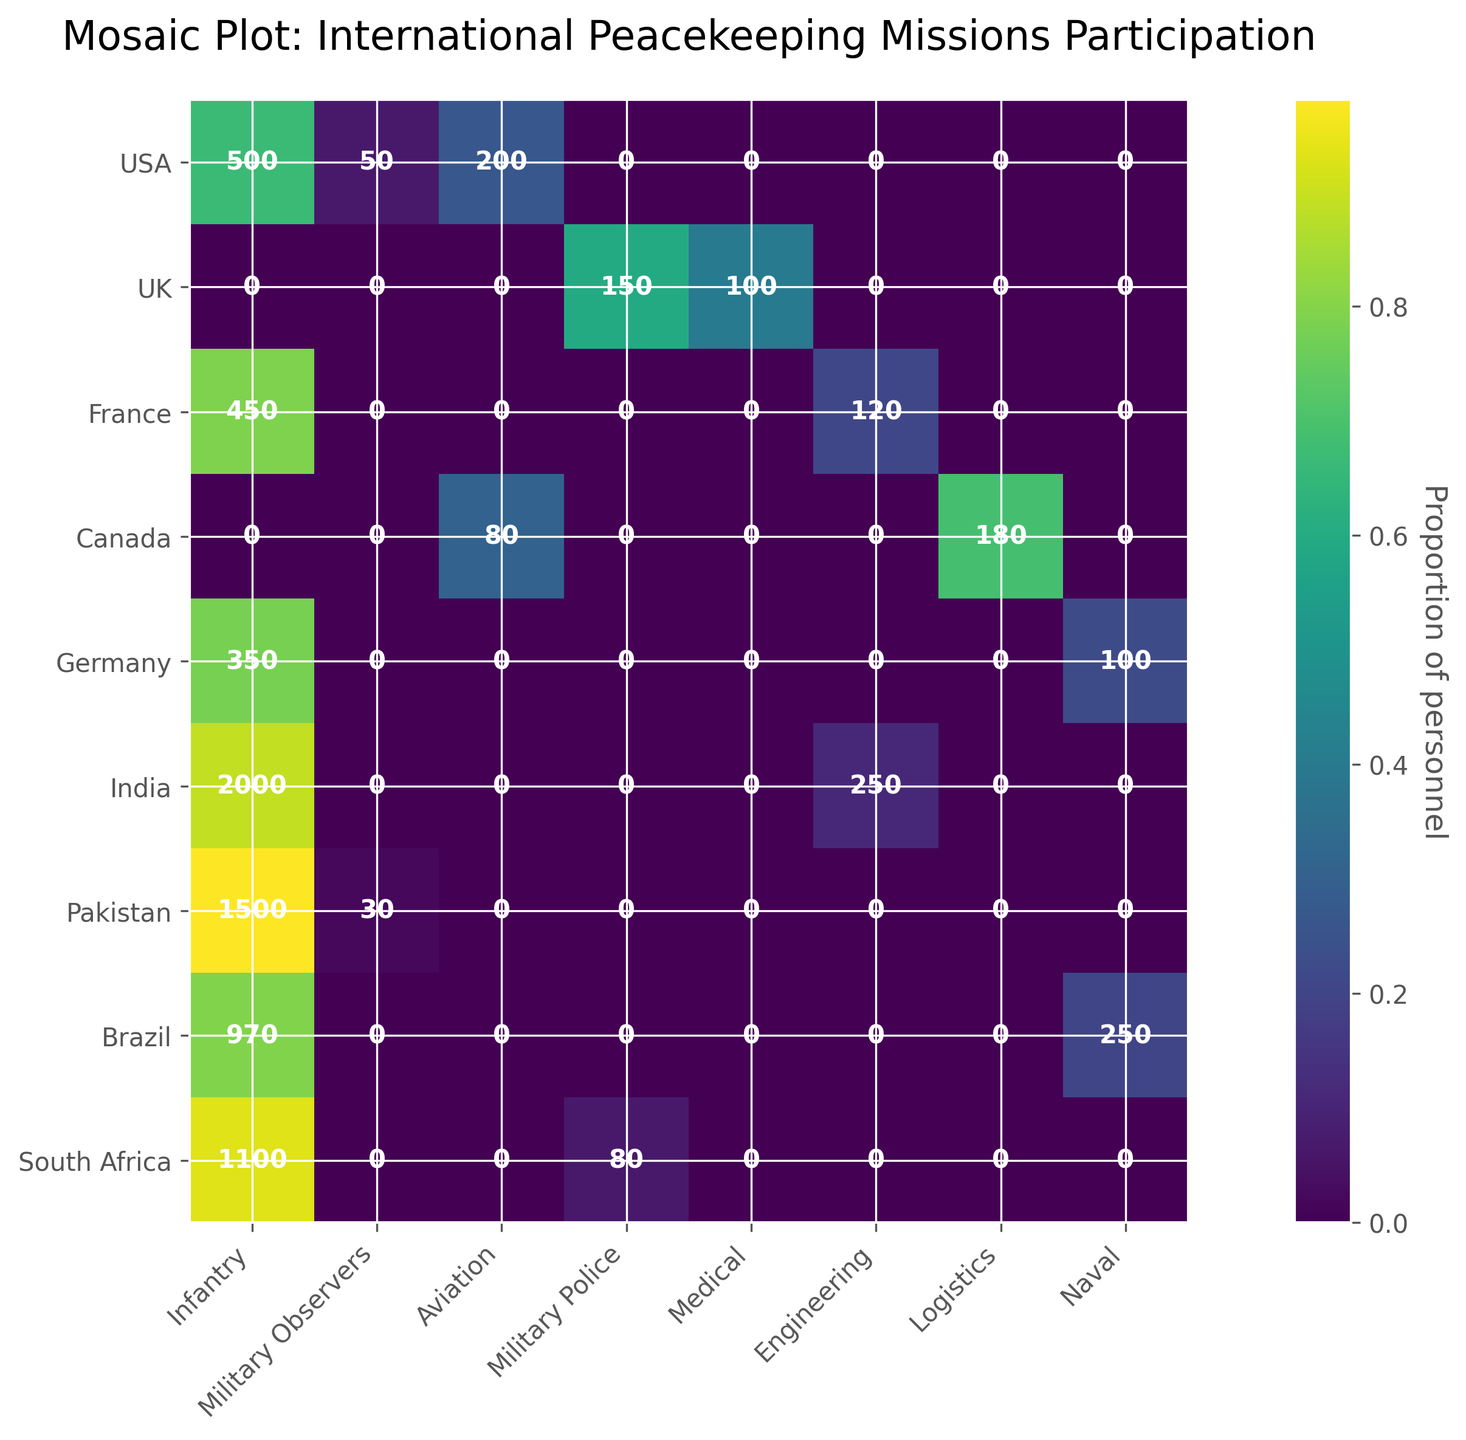Which country has the highest number of Infantry personnel? To find the country with the highest number of Infantry personnel, look at the "Infantry" column and identify the number associated with each country. India has 2000 Infantry personnel.
Answer: India What troop type does the UK contribute the least to? To determine the least contributed troop type by the UK, look at the numbers associated with all troop types for the UK and find the minimum. This is the "Medical" with 100 personnel.
Answer: Medical How many total personnel does France contribute across all troop types? Sum the numbers associated with all troop types for France: 450 (Infantry) + 120 (Engineering). Total is 570.
Answer: 570 Which country has the highest proportion of its total personnel in Military Observers? Calculate the proportion of Military Observers for each country by dividing the number of Military Observers by the total personnel for that country and identify the maximum. Pakistan has 30 Military Observers out of 1530 total, which is approximately 1.96%.
Answer: Pakistan Compare the total number of personnel for Naval troop types between Germany and Brazil. Which country has more? Look at the "Naval" column and compare the numbers for Germany and Brazil. Germany has 100, and Brazil has 250. Thus, Brazil has more Naval personnel.
Answer: Brazil Out of the countries listed, which one has the most diverse contribution in terms of different troop types? To determine the country with the most diverse contribution, count the number of different troop types each country contributes to and identify the maximum. USA contributes to Infantry, Military Observers, and Aviation, totaling 3. UK contributes to Military Police and Medical, totaling 2. France contributes to Infantry and Engineering, totaling 2. Canada contributes to Logistics and Aviation, totaling 2. Germany contributes to Infantry and Naval, totaling 2. India contributes to Infantry and Engineering, totaling 2. Pakistan contributes to Infantry and Military Observers, totaling 2. Brazil contributes to Infantry and Naval, totaling 2. South Africa contributes to Infantry and Military Police, totaling 2. USA has the most diverse contribution with 3 different troop types.
Answer: USA What's the difference in the number of Infantry personnel between India and South Africa? Subtract South Africa’s Infantry personnel (1100) from India’s Infantry personnel (2000). The difference is 900.
Answer: 900 Which country's contribution to MINUSMA involves Aviation personnel? Look for the country associated with MINUSMA and Aviation. The country is Canada with 80 personnel.
Answer: Canada Which country has a significant contribution to UNIFIL in the Naval troop type? Look at the "Naval" column for UNIFIL and find the associated country. Brazil contributes 250 personnel.
Answer: Brazil 